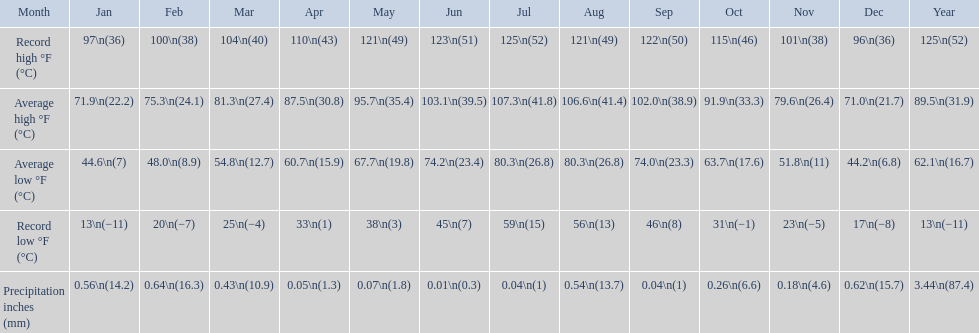For what duration was the average monthly temperature 100 degrees or higher? 4 months. 